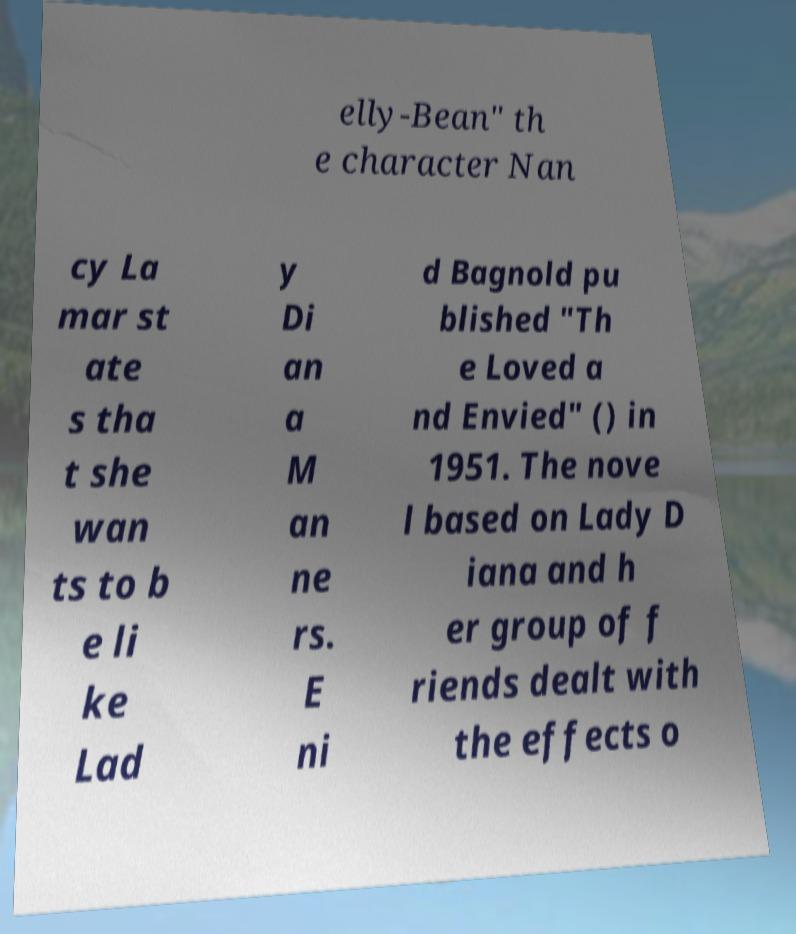There's text embedded in this image that I need extracted. Can you transcribe it verbatim? elly-Bean" th e character Nan cy La mar st ate s tha t she wan ts to b e li ke Lad y Di an a M an ne rs. E ni d Bagnold pu blished "Th e Loved a nd Envied" () in 1951. The nove l based on Lady D iana and h er group of f riends dealt with the effects o 